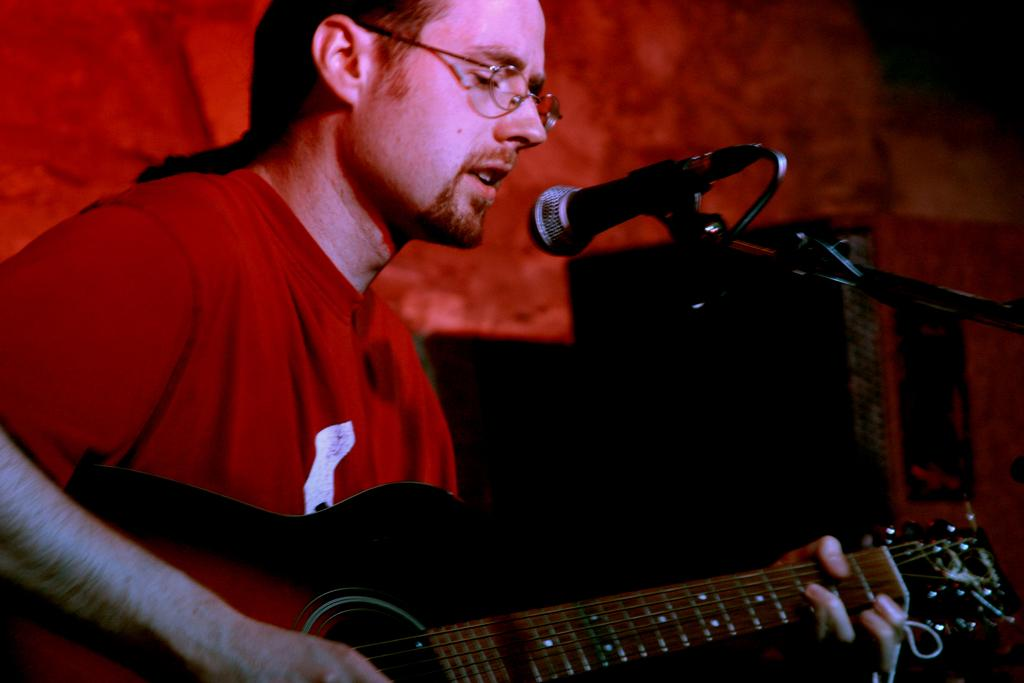What is the man in the image doing? The man is singing in the image. What is the man holding while singing? The man is holding a microphone and a guitar. What type of monkey is playing the guitar in the image? There is no monkey present in the image, and therefore no such activity can be observed. 